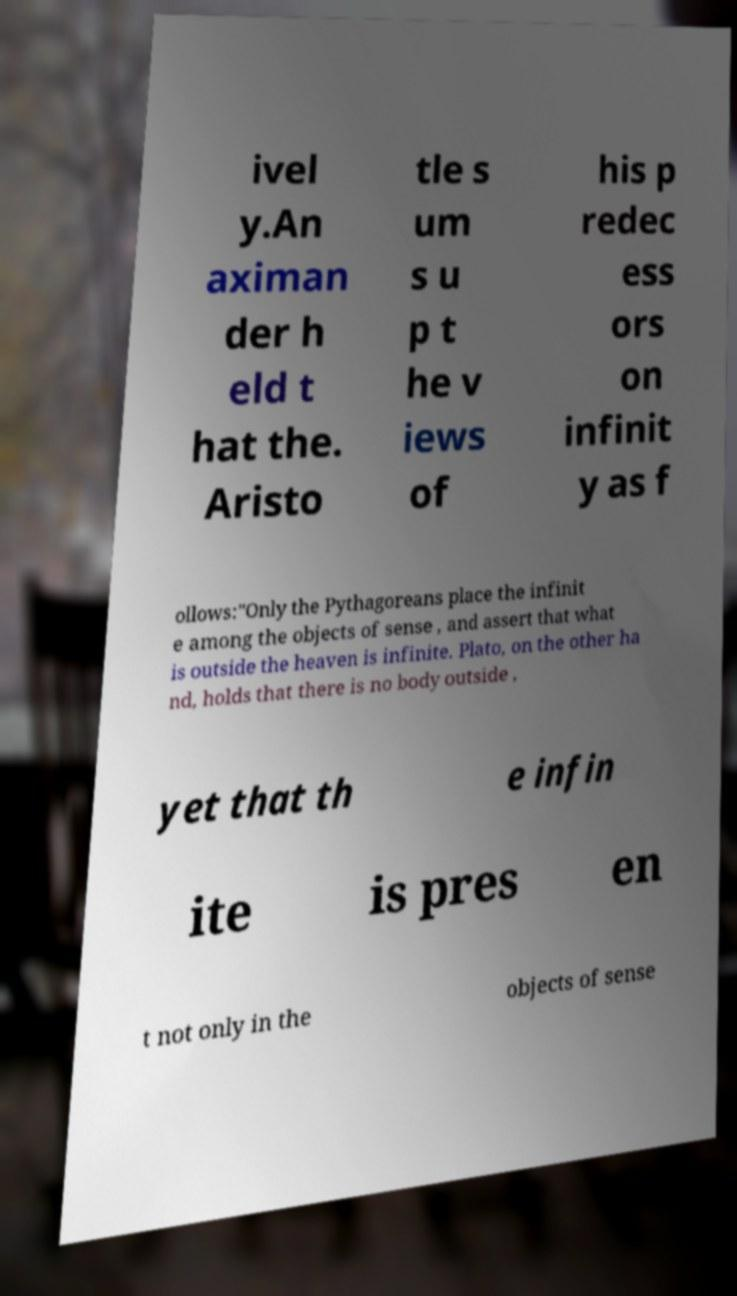Can you accurately transcribe the text from the provided image for me? ivel y.An aximan der h eld t hat the. Aristo tle s um s u p t he v iews of his p redec ess ors on infinit y as f ollows:"Only the Pythagoreans place the infinit e among the objects of sense , and assert that what is outside the heaven is infinite. Plato, on the other ha nd, holds that there is no body outside , yet that th e infin ite is pres en t not only in the objects of sense 